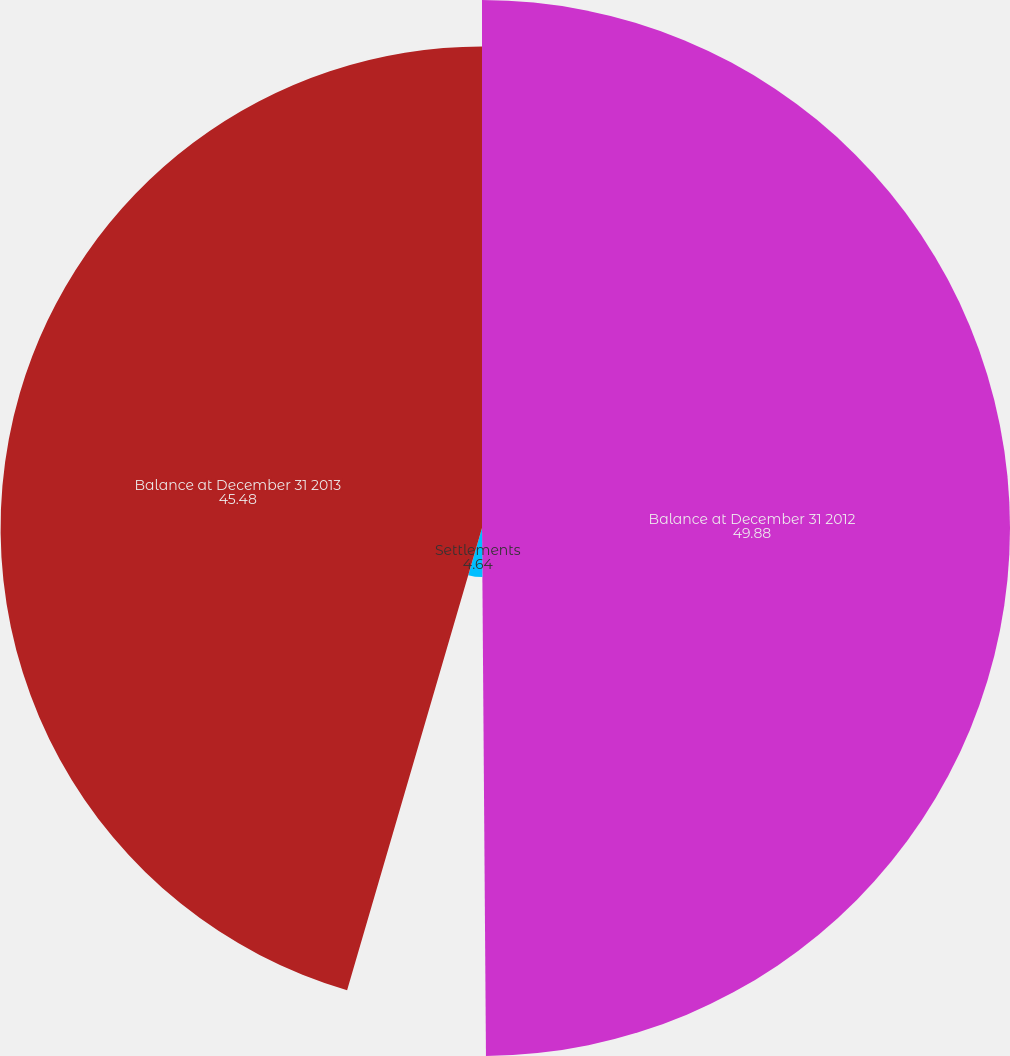Convert chart. <chart><loc_0><loc_0><loc_500><loc_500><pie_chart><fcel>Balance at December 31 2012<fcel>Settlements<fcel>Balance at December 31 2013<nl><fcel>49.88%<fcel>4.64%<fcel>45.48%<nl></chart> 